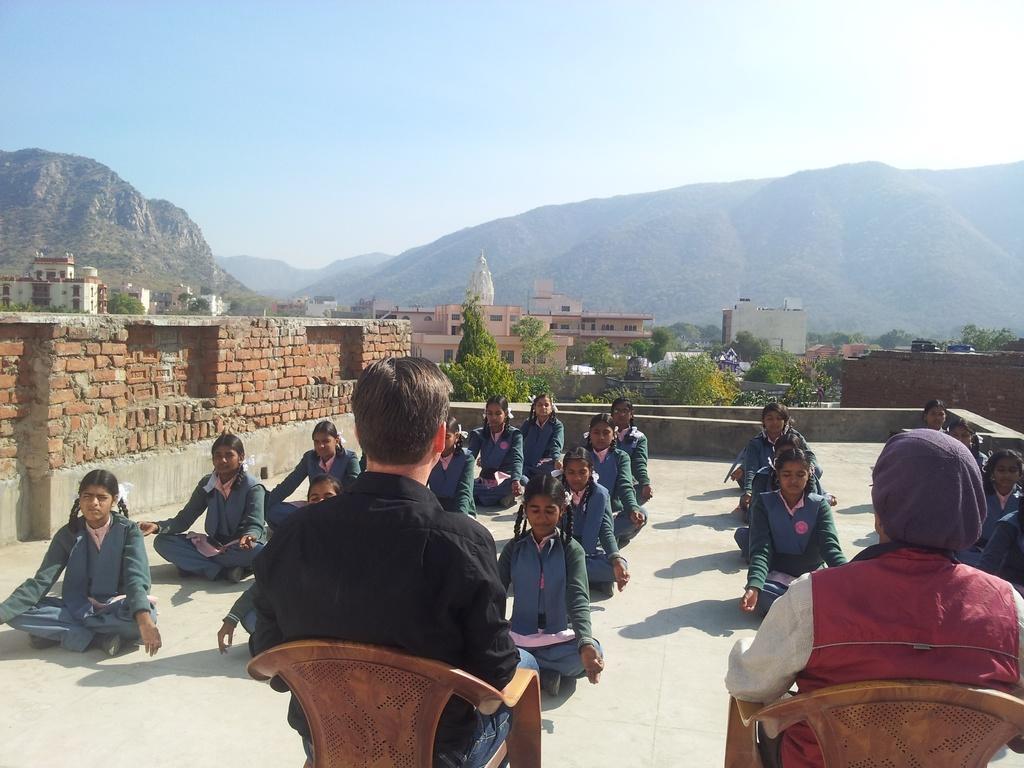Could you give a brief overview of what you see in this image? In this image we can see a few people sitting and doing meditation, in front of them, we can see a two persons sitting on the chairs, there are some buildings, trees and mountains, in the background we can see the sky. 